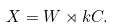Convert formula to latex. <formula><loc_0><loc_0><loc_500><loc_500>X = W \rtimes k C .</formula> 